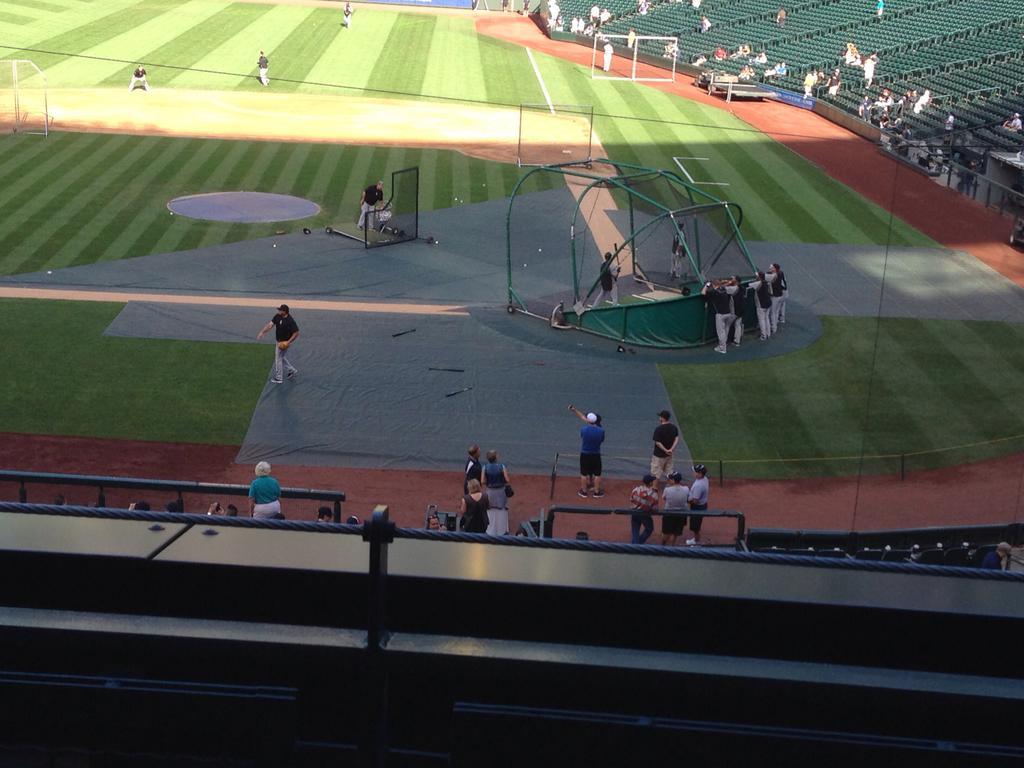How would you summarize this image in a sentence or two? In this picture, we can see stadium, we can see a few people, ground with grass and some objects like nets, poles, and we can see chairs, and fencing. 